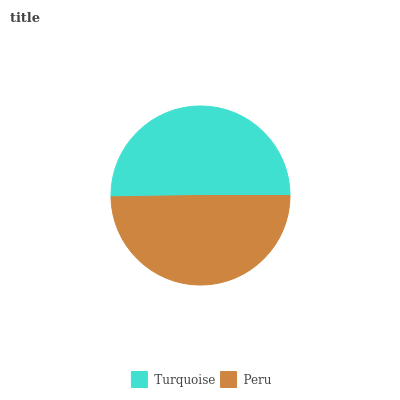Is Peru the minimum?
Answer yes or no. Yes. Is Turquoise the maximum?
Answer yes or no. Yes. Is Peru the maximum?
Answer yes or no. No. Is Turquoise greater than Peru?
Answer yes or no. Yes. Is Peru less than Turquoise?
Answer yes or no. Yes. Is Peru greater than Turquoise?
Answer yes or no. No. Is Turquoise less than Peru?
Answer yes or no. No. Is Turquoise the high median?
Answer yes or no. Yes. Is Peru the low median?
Answer yes or no. Yes. Is Peru the high median?
Answer yes or no. No. Is Turquoise the low median?
Answer yes or no. No. 